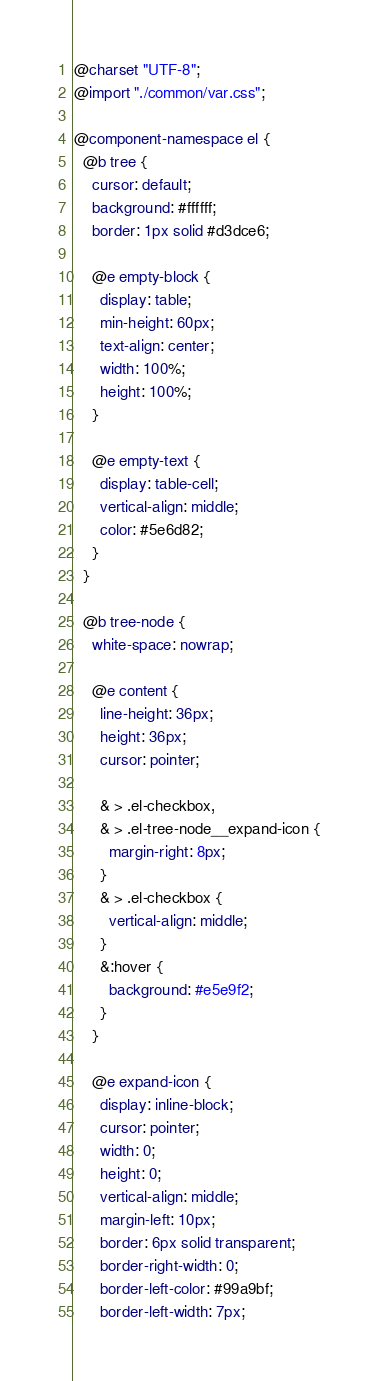<code> <loc_0><loc_0><loc_500><loc_500><_CSS_>@charset "UTF-8";
@import "./common/var.css";

@component-namespace el {
  @b tree {
    cursor: default;
    background: #ffffff;
    border: 1px solid #d3dce6;

    @e empty-block {
      display: table;
      min-height: 60px;
      text-align: center;
      width: 100%;
      height: 100%;
    }

    @e empty-text {
      display: table-cell;
      vertical-align: middle;
      color: #5e6d82;
    }
  }

  @b tree-node {
    white-space: nowrap;

    @e content {
      line-height: 36px;
      height: 36px;
      cursor: pointer;

      & > .el-checkbox,
      & > .el-tree-node__expand-icon {
        margin-right: 8px;
      }
      & > .el-checkbox {
        vertical-align: middle;
      }
      &:hover {
        background: #e5e9f2;
      }
    }

    @e expand-icon {
      display: inline-block;
      cursor: pointer;
      width: 0;
      height: 0;
      vertical-align: middle;
      margin-left: 10px;
      border: 6px solid transparent;
      border-right-width: 0;
      border-left-color: #99a9bf;
      border-left-width: 7px;
</code> 